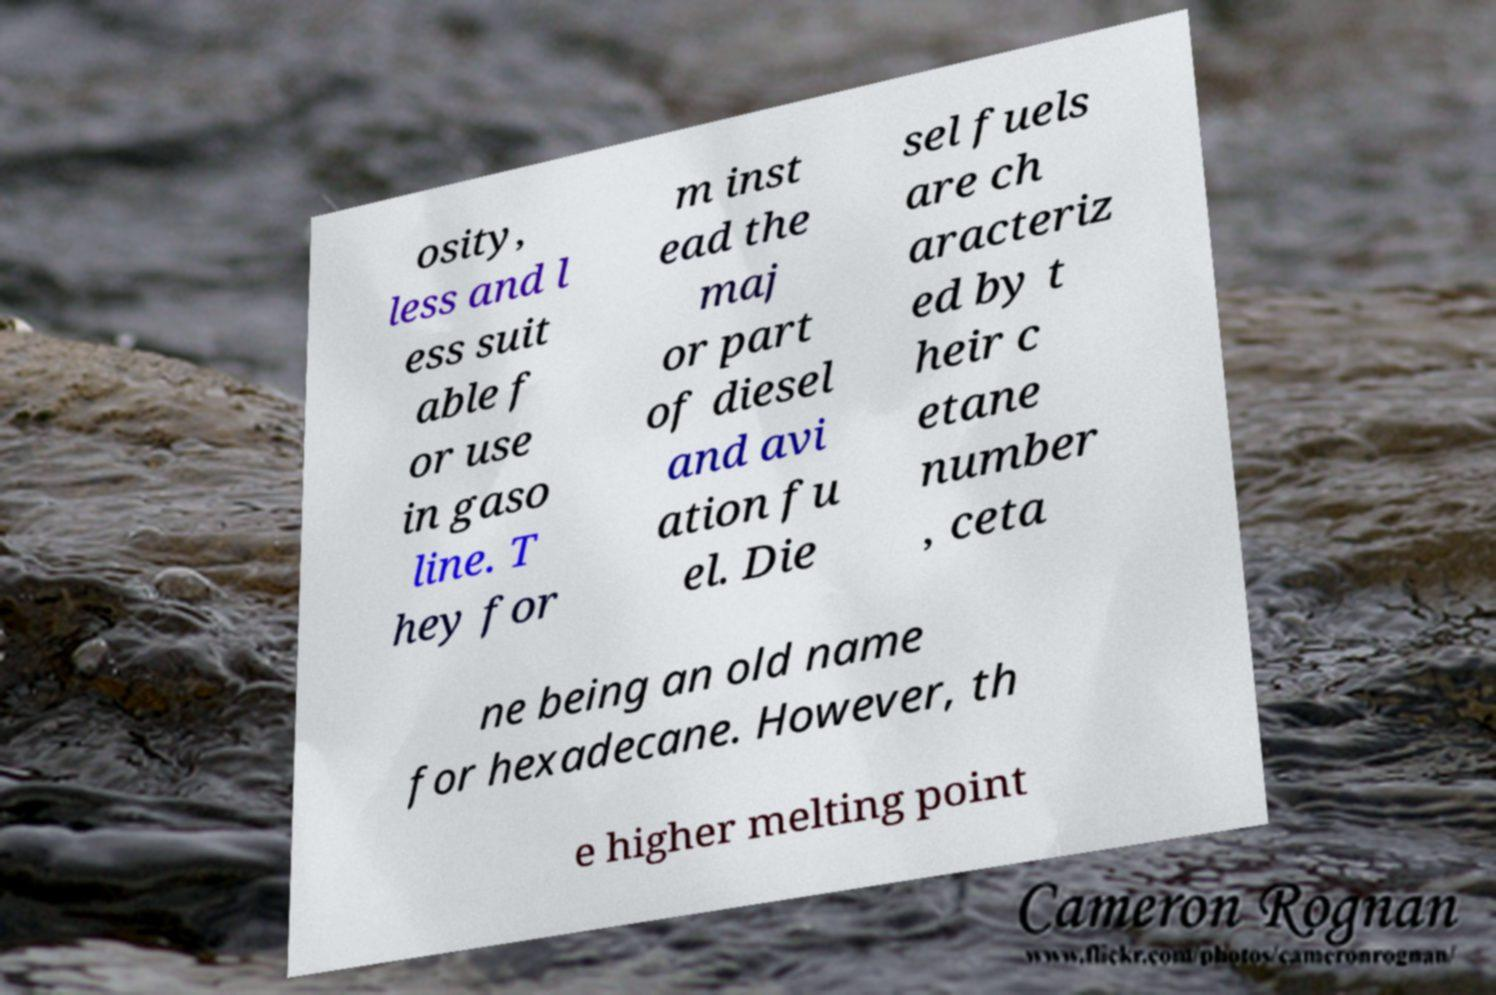Can you read and provide the text displayed in the image?This photo seems to have some interesting text. Can you extract and type it out for me? osity, less and l ess suit able f or use in gaso line. T hey for m inst ead the maj or part of diesel and avi ation fu el. Die sel fuels are ch aracteriz ed by t heir c etane number , ceta ne being an old name for hexadecane. However, th e higher melting point 